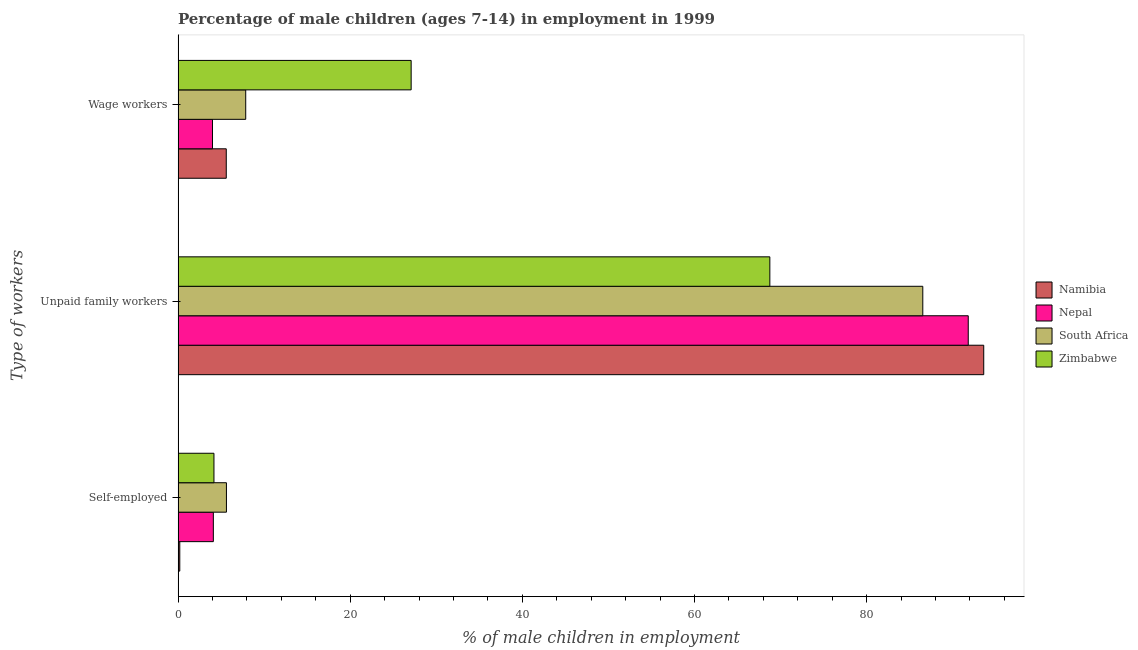How many different coloured bars are there?
Provide a short and direct response. 4. How many groups of bars are there?
Make the answer very short. 3. Are the number of bars per tick equal to the number of legend labels?
Make the answer very short. Yes. Are the number of bars on each tick of the Y-axis equal?
Your answer should be very brief. Yes. How many bars are there on the 1st tick from the top?
Make the answer very short. 4. How many bars are there on the 1st tick from the bottom?
Provide a short and direct response. 4. What is the label of the 1st group of bars from the top?
Make the answer very short. Wage workers. What is the percentage of children employed as wage workers in South Africa?
Your response must be concise. 7.86. Across all countries, what is the maximum percentage of children employed as wage workers?
Provide a short and direct response. 27.08. Across all countries, what is the minimum percentage of children employed as unpaid family workers?
Make the answer very short. 68.75. In which country was the percentage of children employed as unpaid family workers maximum?
Give a very brief answer. Namibia. In which country was the percentage of children employed as unpaid family workers minimum?
Give a very brief answer. Zimbabwe. What is the total percentage of self employed children in the graph?
Give a very brief answer. 14.09. What is the difference between the percentage of children employed as unpaid family workers in Namibia and that in South Africa?
Give a very brief answer. 7.08. What is the difference between the percentage of children employed as unpaid family workers in Zimbabwe and the percentage of children employed as wage workers in Nepal?
Offer a terse response. 64.75. What is the average percentage of self employed children per country?
Your answer should be compact. 3.52. What is the difference between the percentage of self employed children and percentage of children employed as wage workers in Nepal?
Your answer should be very brief. 0.1. What is the ratio of the percentage of children employed as wage workers in Zimbabwe to that in Nepal?
Give a very brief answer. 6.77. Is the percentage of children employed as unpaid family workers in South Africa less than that in Namibia?
Offer a very short reply. Yes. What is the difference between the highest and the second highest percentage of children employed as unpaid family workers?
Provide a short and direct response. 1.8. What is the difference between the highest and the lowest percentage of children employed as unpaid family workers?
Your response must be concise. 24.85. What does the 3rd bar from the top in Wage workers represents?
Provide a succinct answer. Nepal. What does the 1st bar from the bottom in Unpaid family workers represents?
Provide a short and direct response. Namibia. How many bars are there?
Offer a very short reply. 12. Are all the bars in the graph horizontal?
Ensure brevity in your answer.  Yes. How many countries are there in the graph?
Provide a succinct answer. 4. What is the title of the graph?
Offer a terse response. Percentage of male children (ages 7-14) in employment in 1999. What is the label or title of the X-axis?
Keep it short and to the point. % of male children in employment. What is the label or title of the Y-axis?
Your answer should be very brief. Type of workers. What is the % of male children in employment in South Africa in Self-employed?
Your answer should be very brief. 5.62. What is the % of male children in employment in Zimbabwe in Self-employed?
Provide a succinct answer. 4.17. What is the % of male children in employment of Namibia in Unpaid family workers?
Give a very brief answer. 93.6. What is the % of male children in employment of Nepal in Unpaid family workers?
Make the answer very short. 91.8. What is the % of male children in employment in South Africa in Unpaid family workers?
Offer a terse response. 86.52. What is the % of male children in employment in Zimbabwe in Unpaid family workers?
Your response must be concise. 68.75. What is the % of male children in employment in Nepal in Wage workers?
Make the answer very short. 4. What is the % of male children in employment of South Africa in Wage workers?
Your answer should be very brief. 7.86. What is the % of male children in employment of Zimbabwe in Wage workers?
Keep it short and to the point. 27.08. Across all Type of workers, what is the maximum % of male children in employment in Namibia?
Offer a very short reply. 93.6. Across all Type of workers, what is the maximum % of male children in employment in Nepal?
Offer a terse response. 91.8. Across all Type of workers, what is the maximum % of male children in employment of South Africa?
Offer a very short reply. 86.52. Across all Type of workers, what is the maximum % of male children in employment of Zimbabwe?
Give a very brief answer. 68.75. Across all Type of workers, what is the minimum % of male children in employment of South Africa?
Your answer should be compact. 5.62. Across all Type of workers, what is the minimum % of male children in employment of Zimbabwe?
Ensure brevity in your answer.  4.17. What is the total % of male children in employment of Namibia in the graph?
Keep it short and to the point. 99.4. What is the total % of male children in employment of Nepal in the graph?
Ensure brevity in your answer.  99.9. What is the total % of male children in employment in Zimbabwe in the graph?
Offer a terse response. 100. What is the difference between the % of male children in employment in Namibia in Self-employed and that in Unpaid family workers?
Keep it short and to the point. -93.4. What is the difference between the % of male children in employment in Nepal in Self-employed and that in Unpaid family workers?
Offer a terse response. -87.7. What is the difference between the % of male children in employment in South Africa in Self-employed and that in Unpaid family workers?
Provide a succinct answer. -80.9. What is the difference between the % of male children in employment in Zimbabwe in Self-employed and that in Unpaid family workers?
Provide a short and direct response. -64.58. What is the difference between the % of male children in employment of South Africa in Self-employed and that in Wage workers?
Your answer should be compact. -2.24. What is the difference between the % of male children in employment in Zimbabwe in Self-employed and that in Wage workers?
Keep it short and to the point. -22.91. What is the difference between the % of male children in employment in Nepal in Unpaid family workers and that in Wage workers?
Ensure brevity in your answer.  87.8. What is the difference between the % of male children in employment in South Africa in Unpaid family workers and that in Wage workers?
Offer a very short reply. 78.66. What is the difference between the % of male children in employment of Zimbabwe in Unpaid family workers and that in Wage workers?
Give a very brief answer. 41.67. What is the difference between the % of male children in employment of Namibia in Self-employed and the % of male children in employment of Nepal in Unpaid family workers?
Offer a terse response. -91.6. What is the difference between the % of male children in employment of Namibia in Self-employed and the % of male children in employment of South Africa in Unpaid family workers?
Offer a very short reply. -86.32. What is the difference between the % of male children in employment of Namibia in Self-employed and the % of male children in employment of Zimbabwe in Unpaid family workers?
Give a very brief answer. -68.55. What is the difference between the % of male children in employment in Nepal in Self-employed and the % of male children in employment in South Africa in Unpaid family workers?
Your answer should be very brief. -82.42. What is the difference between the % of male children in employment of Nepal in Self-employed and the % of male children in employment of Zimbabwe in Unpaid family workers?
Keep it short and to the point. -64.65. What is the difference between the % of male children in employment in South Africa in Self-employed and the % of male children in employment in Zimbabwe in Unpaid family workers?
Provide a short and direct response. -63.13. What is the difference between the % of male children in employment of Namibia in Self-employed and the % of male children in employment of Nepal in Wage workers?
Your answer should be compact. -3.8. What is the difference between the % of male children in employment of Namibia in Self-employed and the % of male children in employment of South Africa in Wage workers?
Your response must be concise. -7.66. What is the difference between the % of male children in employment in Namibia in Self-employed and the % of male children in employment in Zimbabwe in Wage workers?
Your answer should be very brief. -26.88. What is the difference between the % of male children in employment in Nepal in Self-employed and the % of male children in employment in South Africa in Wage workers?
Your response must be concise. -3.76. What is the difference between the % of male children in employment of Nepal in Self-employed and the % of male children in employment of Zimbabwe in Wage workers?
Offer a very short reply. -22.98. What is the difference between the % of male children in employment of South Africa in Self-employed and the % of male children in employment of Zimbabwe in Wage workers?
Give a very brief answer. -21.46. What is the difference between the % of male children in employment of Namibia in Unpaid family workers and the % of male children in employment of Nepal in Wage workers?
Offer a terse response. 89.6. What is the difference between the % of male children in employment in Namibia in Unpaid family workers and the % of male children in employment in South Africa in Wage workers?
Offer a very short reply. 85.74. What is the difference between the % of male children in employment of Namibia in Unpaid family workers and the % of male children in employment of Zimbabwe in Wage workers?
Provide a short and direct response. 66.52. What is the difference between the % of male children in employment in Nepal in Unpaid family workers and the % of male children in employment in South Africa in Wage workers?
Give a very brief answer. 83.94. What is the difference between the % of male children in employment of Nepal in Unpaid family workers and the % of male children in employment of Zimbabwe in Wage workers?
Your answer should be very brief. 64.72. What is the difference between the % of male children in employment of South Africa in Unpaid family workers and the % of male children in employment of Zimbabwe in Wage workers?
Offer a very short reply. 59.44. What is the average % of male children in employment in Namibia per Type of workers?
Your response must be concise. 33.13. What is the average % of male children in employment of Nepal per Type of workers?
Provide a succinct answer. 33.3. What is the average % of male children in employment in South Africa per Type of workers?
Offer a terse response. 33.33. What is the average % of male children in employment in Zimbabwe per Type of workers?
Make the answer very short. 33.33. What is the difference between the % of male children in employment in Namibia and % of male children in employment in Nepal in Self-employed?
Make the answer very short. -3.9. What is the difference between the % of male children in employment in Namibia and % of male children in employment in South Africa in Self-employed?
Your response must be concise. -5.42. What is the difference between the % of male children in employment of Namibia and % of male children in employment of Zimbabwe in Self-employed?
Make the answer very short. -3.97. What is the difference between the % of male children in employment of Nepal and % of male children in employment of South Africa in Self-employed?
Provide a short and direct response. -1.52. What is the difference between the % of male children in employment in Nepal and % of male children in employment in Zimbabwe in Self-employed?
Provide a succinct answer. -0.07. What is the difference between the % of male children in employment in South Africa and % of male children in employment in Zimbabwe in Self-employed?
Give a very brief answer. 1.45. What is the difference between the % of male children in employment of Namibia and % of male children in employment of South Africa in Unpaid family workers?
Offer a terse response. 7.08. What is the difference between the % of male children in employment of Namibia and % of male children in employment of Zimbabwe in Unpaid family workers?
Your response must be concise. 24.85. What is the difference between the % of male children in employment in Nepal and % of male children in employment in South Africa in Unpaid family workers?
Your answer should be compact. 5.28. What is the difference between the % of male children in employment in Nepal and % of male children in employment in Zimbabwe in Unpaid family workers?
Your response must be concise. 23.05. What is the difference between the % of male children in employment in South Africa and % of male children in employment in Zimbabwe in Unpaid family workers?
Your response must be concise. 17.77. What is the difference between the % of male children in employment of Namibia and % of male children in employment of Nepal in Wage workers?
Keep it short and to the point. 1.6. What is the difference between the % of male children in employment of Namibia and % of male children in employment of South Africa in Wage workers?
Provide a short and direct response. -2.26. What is the difference between the % of male children in employment in Namibia and % of male children in employment in Zimbabwe in Wage workers?
Your answer should be compact. -21.48. What is the difference between the % of male children in employment of Nepal and % of male children in employment of South Africa in Wage workers?
Make the answer very short. -3.86. What is the difference between the % of male children in employment in Nepal and % of male children in employment in Zimbabwe in Wage workers?
Provide a succinct answer. -23.08. What is the difference between the % of male children in employment of South Africa and % of male children in employment of Zimbabwe in Wage workers?
Your answer should be compact. -19.22. What is the ratio of the % of male children in employment in Namibia in Self-employed to that in Unpaid family workers?
Give a very brief answer. 0. What is the ratio of the % of male children in employment of Nepal in Self-employed to that in Unpaid family workers?
Offer a very short reply. 0.04. What is the ratio of the % of male children in employment of South Africa in Self-employed to that in Unpaid family workers?
Ensure brevity in your answer.  0.07. What is the ratio of the % of male children in employment in Zimbabwe in Self-employed to that in Unpaid family workers?
Offer a terse response. 0.06. What is the ratio of the % of male children in employment in Namibia in Self-employed to that in Wage workers?
Give a very brief answer. 0.04. What is the ratio of the % of male children in employment of Nepal in Self-employed to that in Wage workers?
Ensure brevity in your answer.  1.02. What is the ratio of the % of male children in employment in South Africa in Self-employed to that in Wage workers?
Provide a short and direct response. 0.71. What is the ratio of the % of male children in employment of Zimbabwe in Self-employed to that in Wage workers?
Give a very brief answer. 0.15. What is the ratio of the % of male children in employment in Namibia in Unpaid family workers to that in Wage workers?
Give a very brief answer. 16.71. What is the ratio of the % of male children in employment in Nepal in Unpaid family workers to that in Wage workers?
Provide a succinct answer. 22.95. What is the ratio of the % of male children in employment of South Africa in Unpaid family workers to that in Wage workers?
Make the answer very short. 11.01. What is the ratio of the % of male children in employment of Zimbabwe in Unpaid family workers to that in Wage workers?
Your response must be concise. 2.54. What is the difference between the highest and the second highest % of male children in employment in Namibia?
Your answer should be very brief. 88. What is the difference between the highest and the second highest % of male children in employment in Nepal?
Ensure brevity in your answer.  87.7. What is the difference between the highest and the second highest % of male children in employment in South Africa?
Offer a very short reply. 78.66. What is the difference between the highest and the second highest % of male children in employment of Zimbabwe?
Make the answer very short. 41.67. What is the difference between the highest and the lowest % of male children in employment in Namibia?
Make the answer very short. 93.4. What is the difference between the highest and the lowest % of male children in employment of Nepal?
Make the answer very short. 87.8. What is the difference between the highest and the lowest % of male children in employment of South Africa?
Your response must be concise. 80.9. What is the difference between the highest and the lowest % of male children in employment in Zimbabwe?
Offer a terse response. 64.58. 